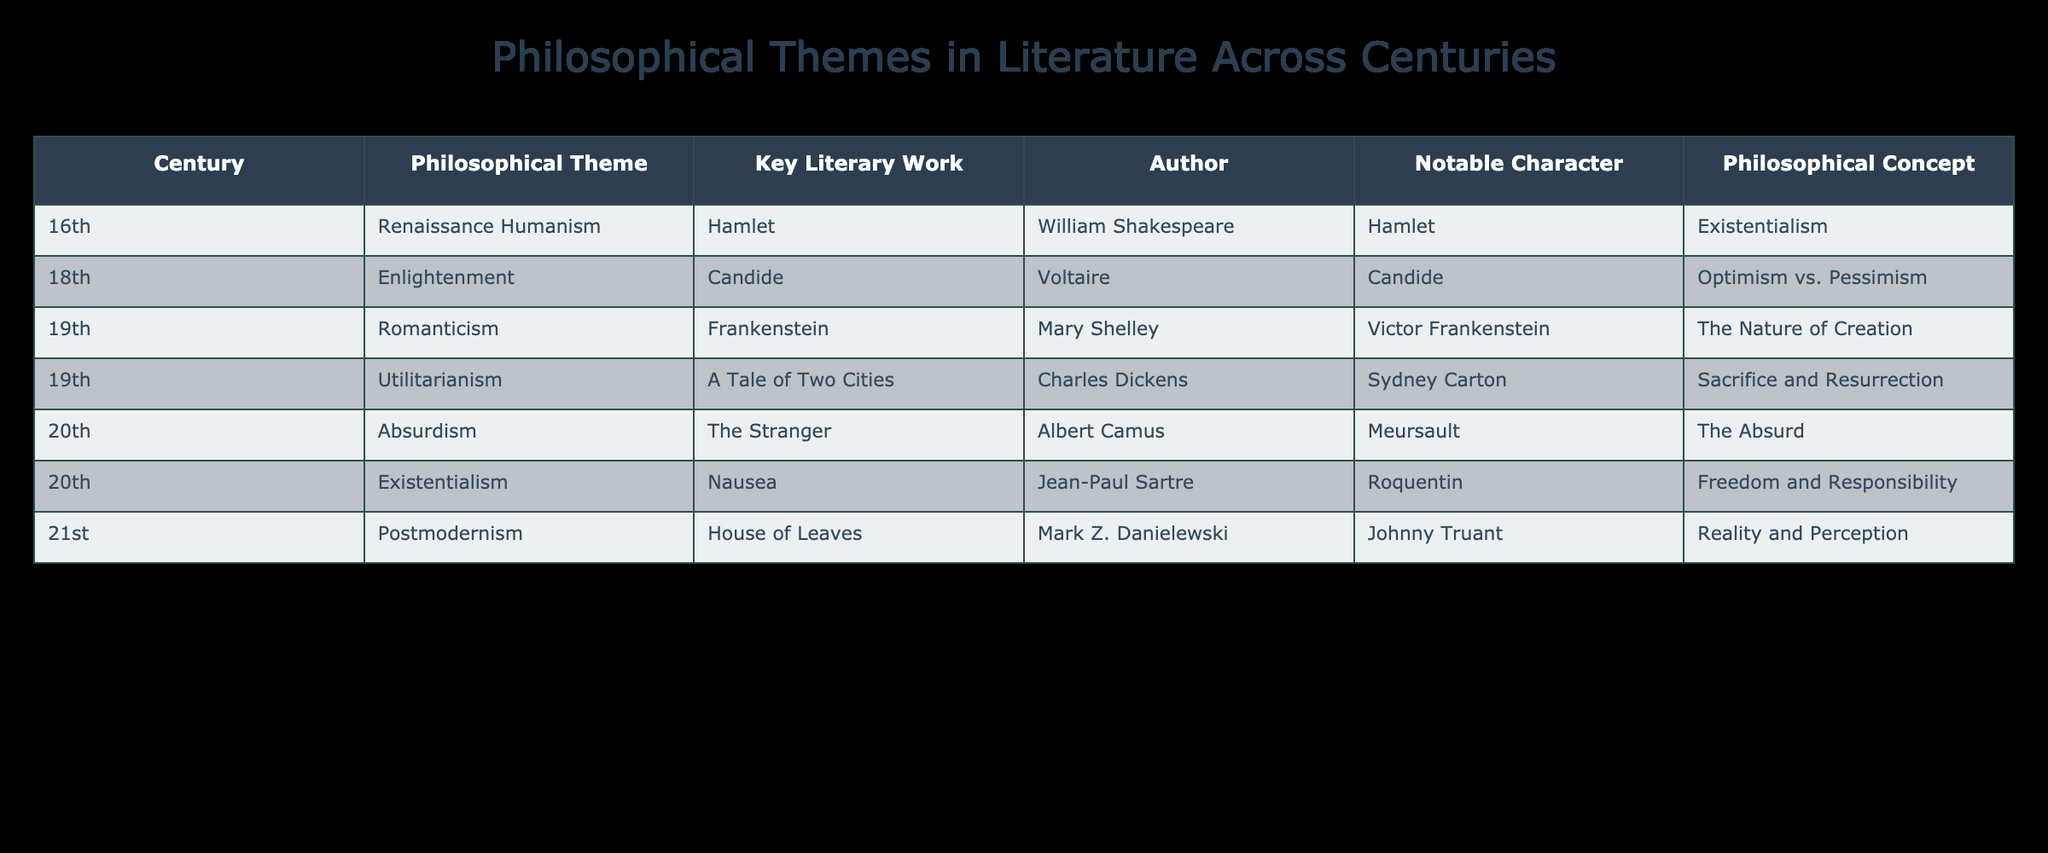What is the philosophical theme associated with "Frankenstein"? Referring to the row that includes "Frankenstein," we can see that the philosophical theme listed is "Romanticism."
Answer: Romanticism Which author is linked to the concept of "The Absurd"? Looking at the row where "The Absurd" is mentioned, the author associated with this concept is "Albert Camus."
Answer: Albert Camus Are there any works that explore the theme of Sacrifice and Resurrection? From the table, we note that "A Tale of Two Cities" discusses Sacrifice and Resurrection, indicating that there is indeed a work exploring this theme.
Answer: Yes What century is associated with the concept of Existentialism? Both "Hamlet" and "Nausea" are listed under the concept of Existentialism, with "Hamlet" in the 16th century and "Nausea" in the 20th century; the earliest occurrence is thus the 16th century.
Answer: 16th century Which key literary work from the 21st century addresses the theme of Reality and Perception? In the table, "House of Leaves" is the key literary work listed for the 21st century that concerns Reality and Perception.
Answer: House of Leaves What is the average number of centuries that the philosophical themes have been explored? There are works from six different centuries listed: 16th, 18th, 19th, 20th, and 21st. The average is calculated by dividing the total number of centuries (5) by the unique occurrences (6), giving us an average of approximately 3.67 rounded up to 4 centuries.
Answer: 4 Is "Sydney Carton" a character associated with the theme of Optimism vs. Pessimism? A review of the table reveals that "Sydney Carton" is linked with "A Tale of Two Cities," which deals with Sacrifice and Resurrection, not Optimism vs. Pessimism. Thus, this fact is false.
Answer: No Which philosophical theme appears most frequently in the table? By examining the table, we find that themes like Existentialism and Sacrifice and Resurrection are addressed multiple times, suggesting that these themes are prominent. However, Existentialism is specifically addressed by two works.
Answer: Existentialism What is the notable character in the key literary work associated with Postmodernism? The table indicates that the character Johnny Truant is noted in the key literary work "House of Leaves," which aligns with Postmodernism.
Answer: Johnny Truant 